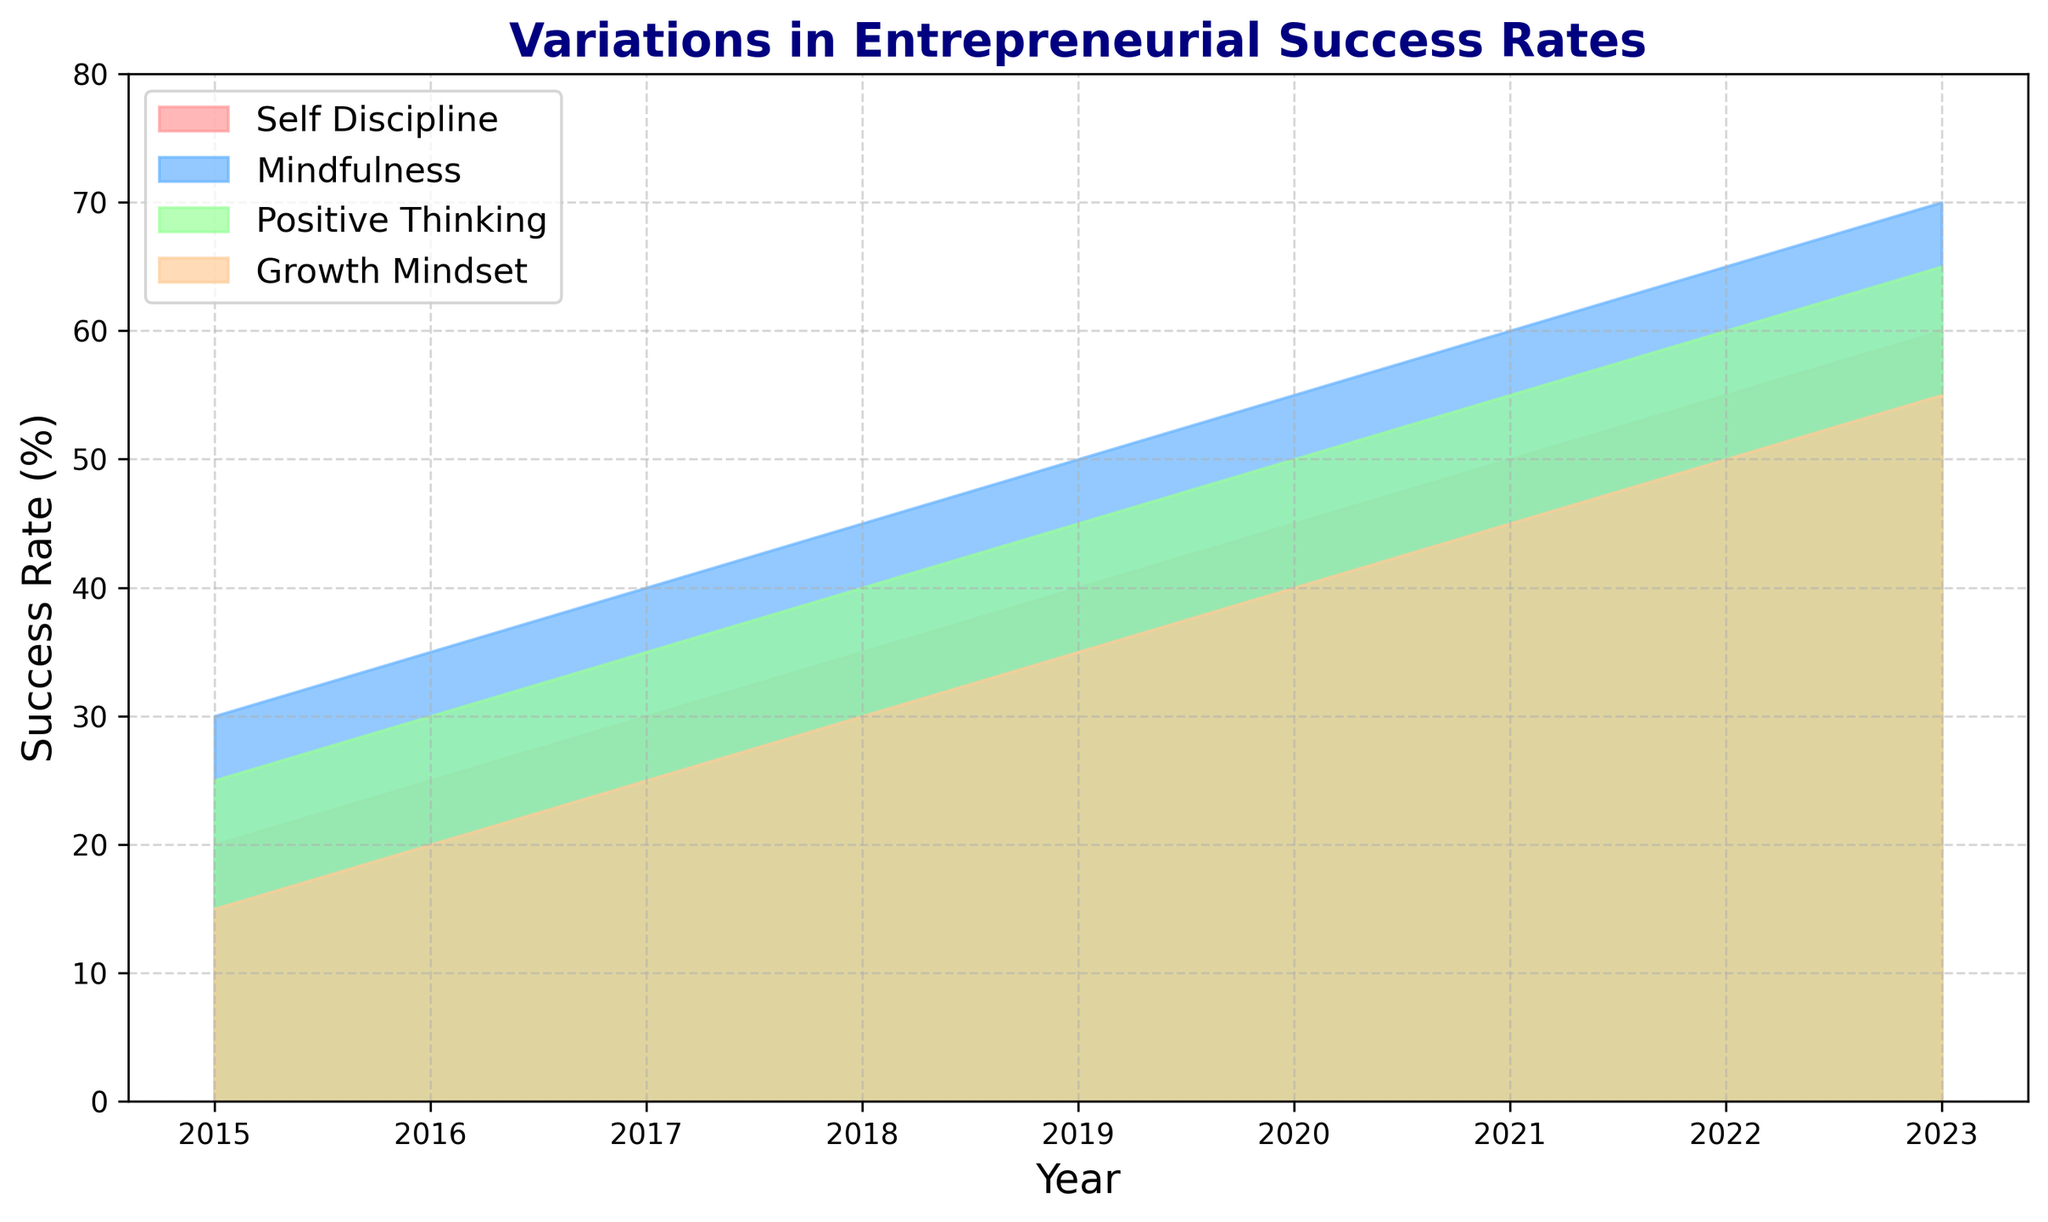Which self-help strategy had the highest success rate in 2023? The highest point on the y-axis for 2023 corresponds to the “mindfulness” line, which reaches 70%.
Answer: Mindfulness Between which two years did "positive thinking" see the largest increase in success rate? Comparing each year, the largest increase for “positive thinking” is seen between 2019 and 2020, rising from 45% to 50%.
Answer: 2019-2020 How much did the success rate of "self-discipline" grow from 2015 to 2023? The success rate of “self-discipline” in 2015 was 20%, and in 2023 was 60%. The increase is 60% - 20% = 40%.
Answer: 40% Which strategy consistently had the lowest success rate over the years? Observing the chart, “growth mindset” consistently appears to be the lowest in all the years listed.
Answer: Growth Mindset In which year did "mindfulness" overtake "self-discipline" in success rate? In 2016, "mindfulness" surpassed "self-discipline" with 35% compared to 25%.
Answer: 2016 What is the difference between the success rates of "positive thinking" and "growth mindset" in 2023? The success rate for “positive thinking” in 2023 is 65%, and for “growth mindset” is 55%. The difference is 65% - 55% = 10%.
Answer: 10% How do the trends in "mindfulness" and "positive thinking" compare from 2015 to 2023? Both trends show a consistent increase. "Mindfulness" goes from 30% to 70%, while "positive thinking" goes from 25% to 65%. Both show steady, linear growth.
Answer: Both increase steadily Which strategy showed an equal success rate at any point, and in which years? In 2020, "self-discipline" and "positive thinking" both showed a success rate of 50%.
Answer: Self-Discipline and Positive Thinking in 2020 What was the average success rate of "growth mindset" from 2015 to 2023? The sum of "growth mindset" success rates from 2015 to 2023 is 15 + 20 + 25 + 30 + 35 + 40 + 45 + 50 + 55 = 315. The average is 315/9 = 35%.
Answer: 35% Which strategy had the maximum rate of increase in any given year, and what was the rate? "Mindfulness" had the maximum rate of increase from 2016 to 2017, with an increase of 5% from 35% to 40%.
Answer: Mindfulness, 5% 